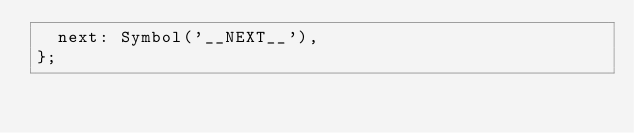<code> <loc_0><loc_0><loc_500><loc_500><_JavaScript_>  next: Symbol('__NEXT__'),
};
</code> 